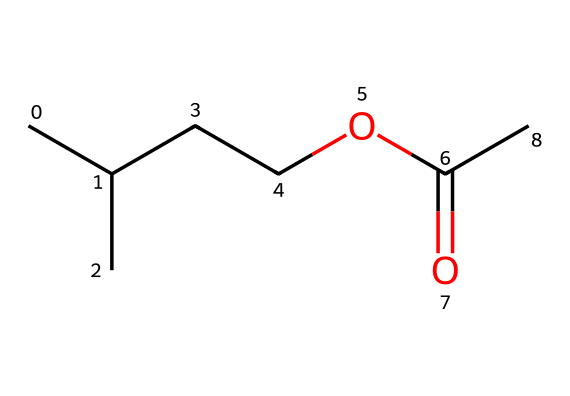What is the molecular formula of isoamyl acetate? To determine the molecular formula, count the number of each type of atom in the SMILES string. There are five carbon (C) atoms, ten hydrogen (H) atoms, and two oxygen (O) atoms present. Thus, the molecular formula is C5H10O2.
Answer: C5H10O2 How many carbon atoms are present in isoamyl acetate? By examining the SMILES representation, we can identify five carbon atoms (C), as denoted by the 'C' characters, which indicates the backbone of the molecule.
Answer: 5 What type of functional group is present in isoamyl acetate? The structural formula indicates the presence of a carbonyl (C=O) adjacent to an ether-like linkage (C-O-C), which is characteristic of esters. This helps identify the functional group as an ester group.
Answer: ester Which part of this chemical is responsible for its banana aroma? The distinctive banana aroma is primarily attributed to the isoamyl group (the branched section part of the molecule), which is a key contributor to the fruity scent associated with isoamyl acetate.
Answer: isoamyl group What is the structural feature indicating that this molecule is an ester? In the SMILES string, the presence of carbonyl (C=O) followed by a single bond connecting to another carbon atom (C-O) indicates a carboxylate linkage, characteristic of esters.
Answer: carbonyl group What is the total number of atoms present in isoamyl acetate? To find the total number of atoms, sum the individual counts: 5 carbon (C) + 10 hydrogen (H) + 2 oxygen (O), resulting in a total of 17 atoms.
Answer: 17 